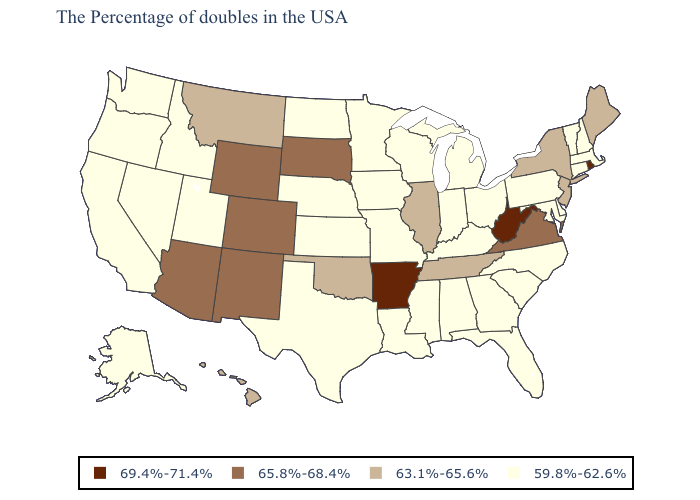Does Illinois have a higher value than Oklahoma?
Write a very short answer. No. Name the states that have a value in the range 65.8%-68.4%?
Concise answer only. Virginia, South Dakota, Wyoming, Colorado, New Mexico, Arizona. What is the value of Washington?
Write a very short answer. 59.8%-62.6%. What is the lowest value in states that border Minnesota?
Give a very brief answer. 59.8%-62.6%. What is the value of Oregon?
Write a very short answer. 59.8%-62.6%. Among the states that border Kentucky , which have the lowest value?
Keep it brief. Ohio, Indiana, Missouri. Among the states that border Montana , which have the highest value?
Answer briefly. South Dakota, Wyoming. Among the states that border South Dakota , which have the highest value?
Quick response, please. Wyoming. Name the states that have a value in the range 69.4%-71.4%?
Answer briefly. Rhode Island, West Virginia, Arkansas. Is the legend a continuous bar?
Keep it brief. No. Does the map have missing data?
Keep it brief. No. What is the value of Nebraska?
Quick response, please. 59.8%-62.6%. Name the states that have a value in the range 63.1%-65.6%?
Answer briefly. Maine, New York, New Jersey, Tennessee, Illinois, Oklahoma, Montana, Hawaii. Does the map have missing data?
Be succinct. No. What is the highest value in the USA?
Give a very brief answer. 69.4%-71.4%. 